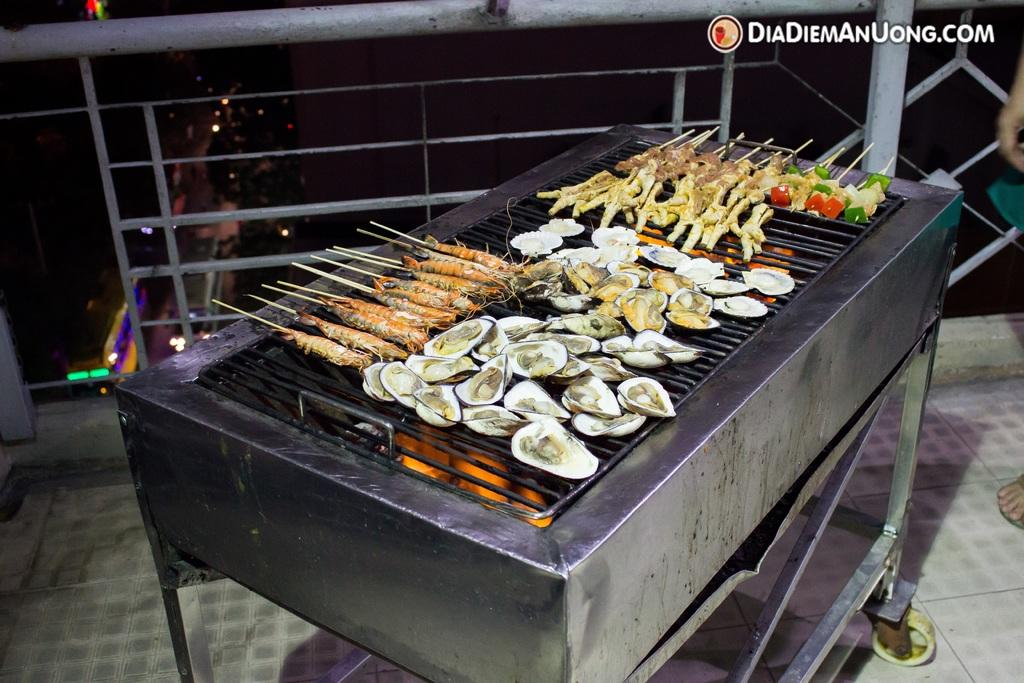<image>
Provide a brief description of the given image. the word Dia is located above the stove with food 